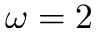<formula> <loc_0><loc_0><loc_500><loc_500>\omega = 2</formula> 